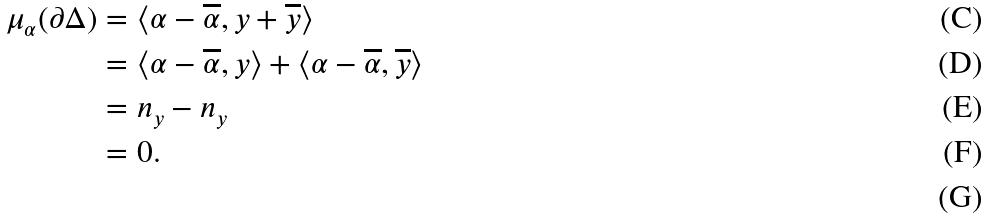Convert formula to latex. <formula><loc_0><loc_0><loc_500><loc_500>\mu _ { \alpha } ( \partial \Delta ) & = \langle \alpha - \overline { \alpha } , y + \overline { y } \rangle \\ & = \langle \alpha - \overline { \alpha } , y \rangle + \langle \alpha - \overline { \alpha } , \overline { y } \rangle \\ & = n _ { y } - n _ { y } \\ & = 0 . \\</formula> 